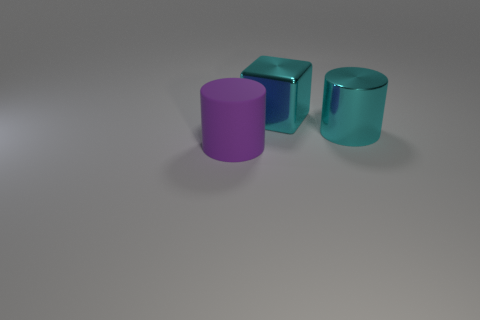Subtract all yellow cylinders. Subtract all gray blocks. How many cylinders are left? 2 Add 1 large cyan cylinders. How many objects exist? 4 Subtract all blocks. How many objects are left? 2 Add 2 big green metallic spheres. How many big green metallic spheres exist? 2 Subtract 0 blue cylinders. How many objects are left? 3 Subtract all cyan metallic cylinders. Subtract all purple rubber things. How many objects are left? 1 Add 2 cyan metal things. How many cyan metal things are left? 4 